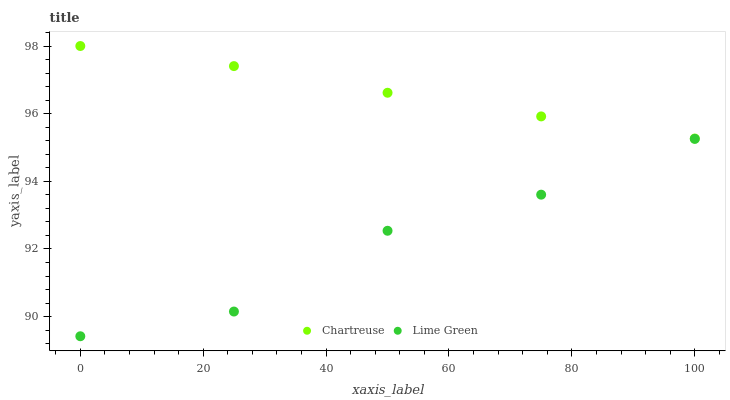Does Lime Green have the minimum area under the curve?
Answer yes or no. Yes. Does Chartreuse have the maximum area under the curve?
Answer yes or no. Yes. Does Lime Green have the maximum area under the curve?
Answer yes or no. No. Is Chartreuse the smoothest?
Answer yes or no. Yes. Is Lime Green the roughest?
Answer yes or no. Yes. Is Lime Green the smoothest?
Answer yes or no. No. Does Lime Green have the lowest value?
Answer yes or no. Yes. Does Chartreuse have the highest value?
Answer yes or no. Yes. Does Lime Green have the highest value?
Answer yes or no. No. Is Lime Green less than Chartreuse?
Answer yes or no. Yes. Is Chartreuse greater than Lime Green?
Answer yes or no. Yes. Does Lime Green intersect Chartreuse?
Answer yes or no. No. 